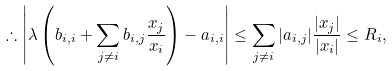Convert formula to latex. <formula><loc_0><loc_0><loc_500><loc_500>\therefore \left | \lambda \left ( b _ { i , i } + \sum _ { j \not = i } b _ { i , j } \frac { x _ { j } } { x _ { i } } \right ) - a _ { i , i } \right | \leq \sum _ { j \not = i } | a _ { i , j } | \frac { | x _ { j } | } { | x _ { i } | } \leq R _ { i } ,</formula> 